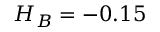<formula> <loc_0><loc_0><loc_500><loc_500>H _ { B } = - 0 . 1 5</formula> 